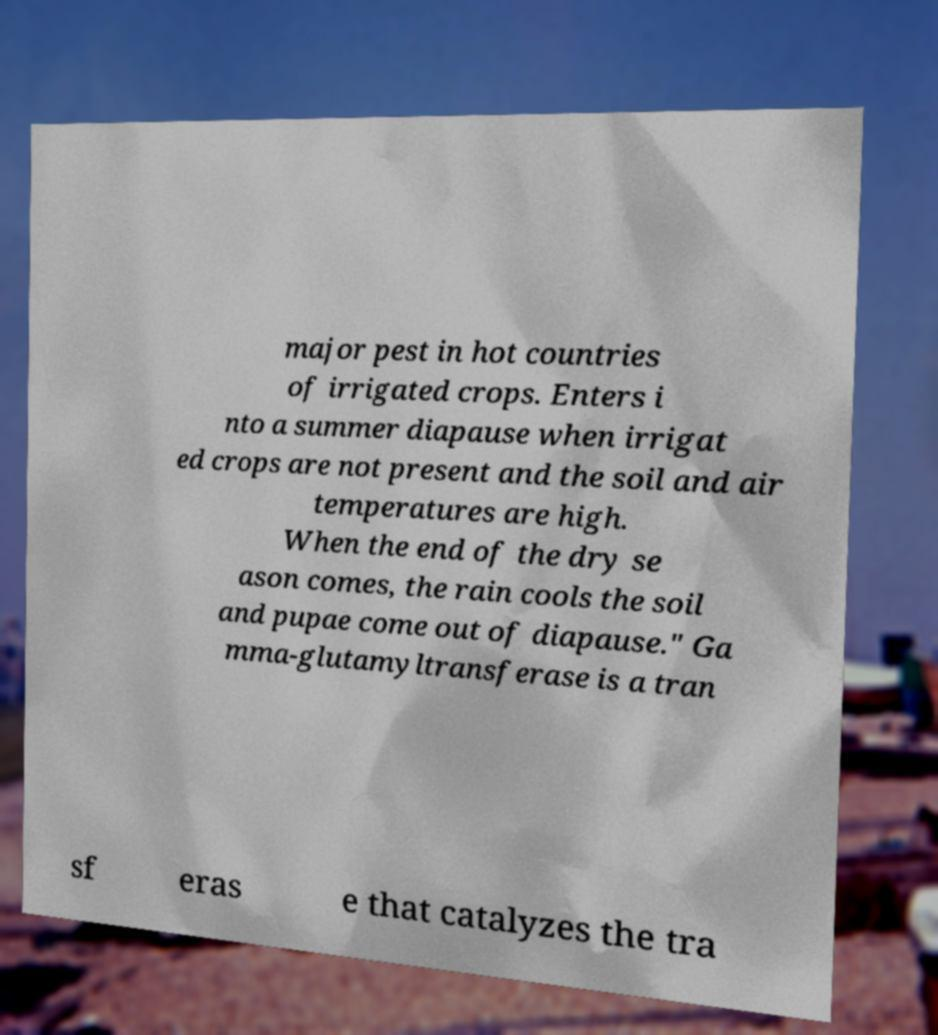Please read and relay the text visible in this image. What does it say? major pest in hot countries of irrigated crops. Enters i nto a summer diapause when irrigat ed crops are not present and the soil and air temperatures are high. When the end of the dry se ason comes, the rain cools the soil and pupae come out of diapause." Ga mma-glutamyltransferase is a tran sf eras e that catalyzes the tra 